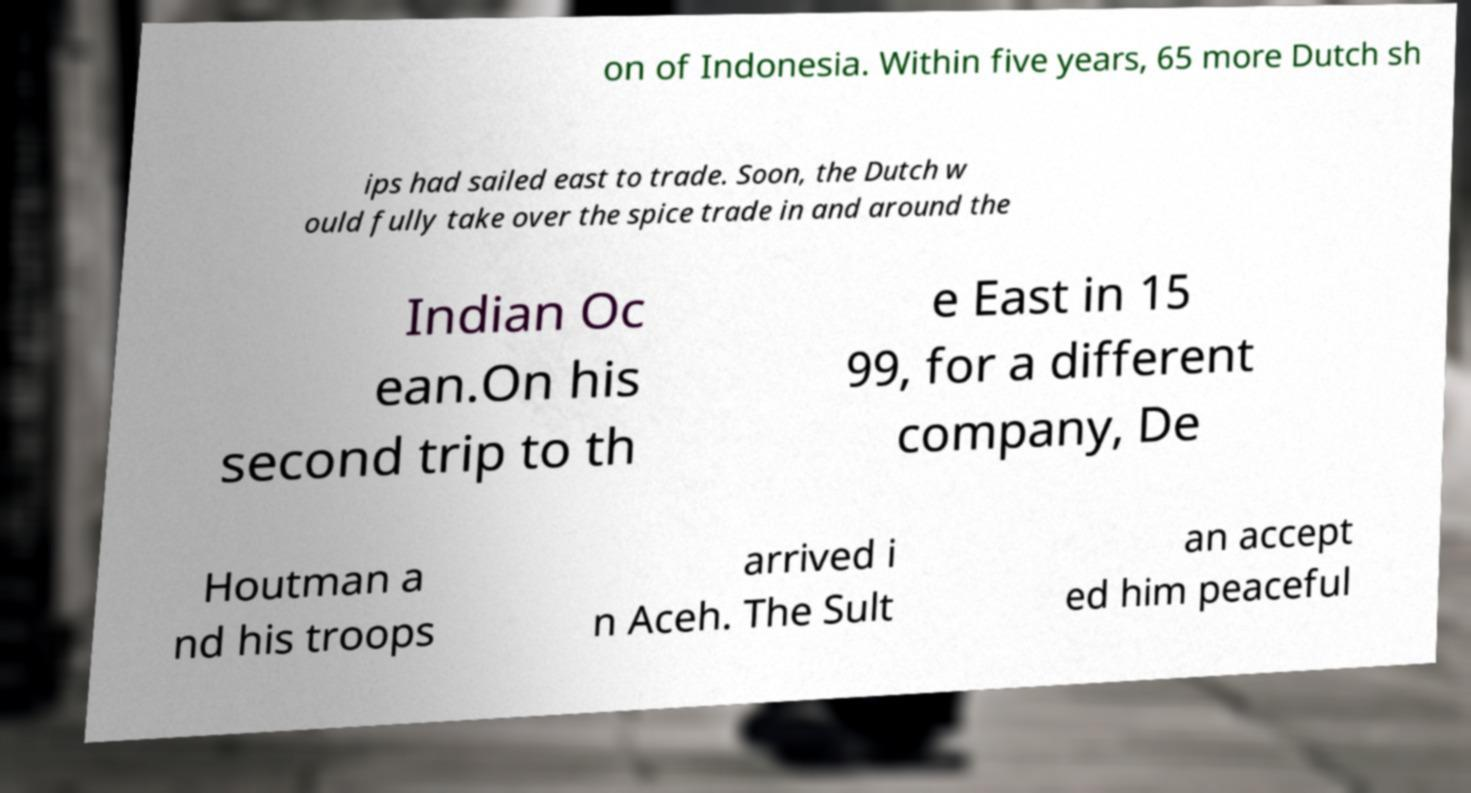There's text embedded in this image that I need extracted. Can you transcribe it verbatim? on of Indonesia. Within five years, 65 more Dutch sh ips had sailed east to trade. Soon, the Dutch w ould fully take over the spice trade in and around the Indian Oc ean.On his second trip to th e East in 15 99, for a different company, De Houtman a nd his troops arrived i n Aceh. The Sult an accept ed him peaceful 